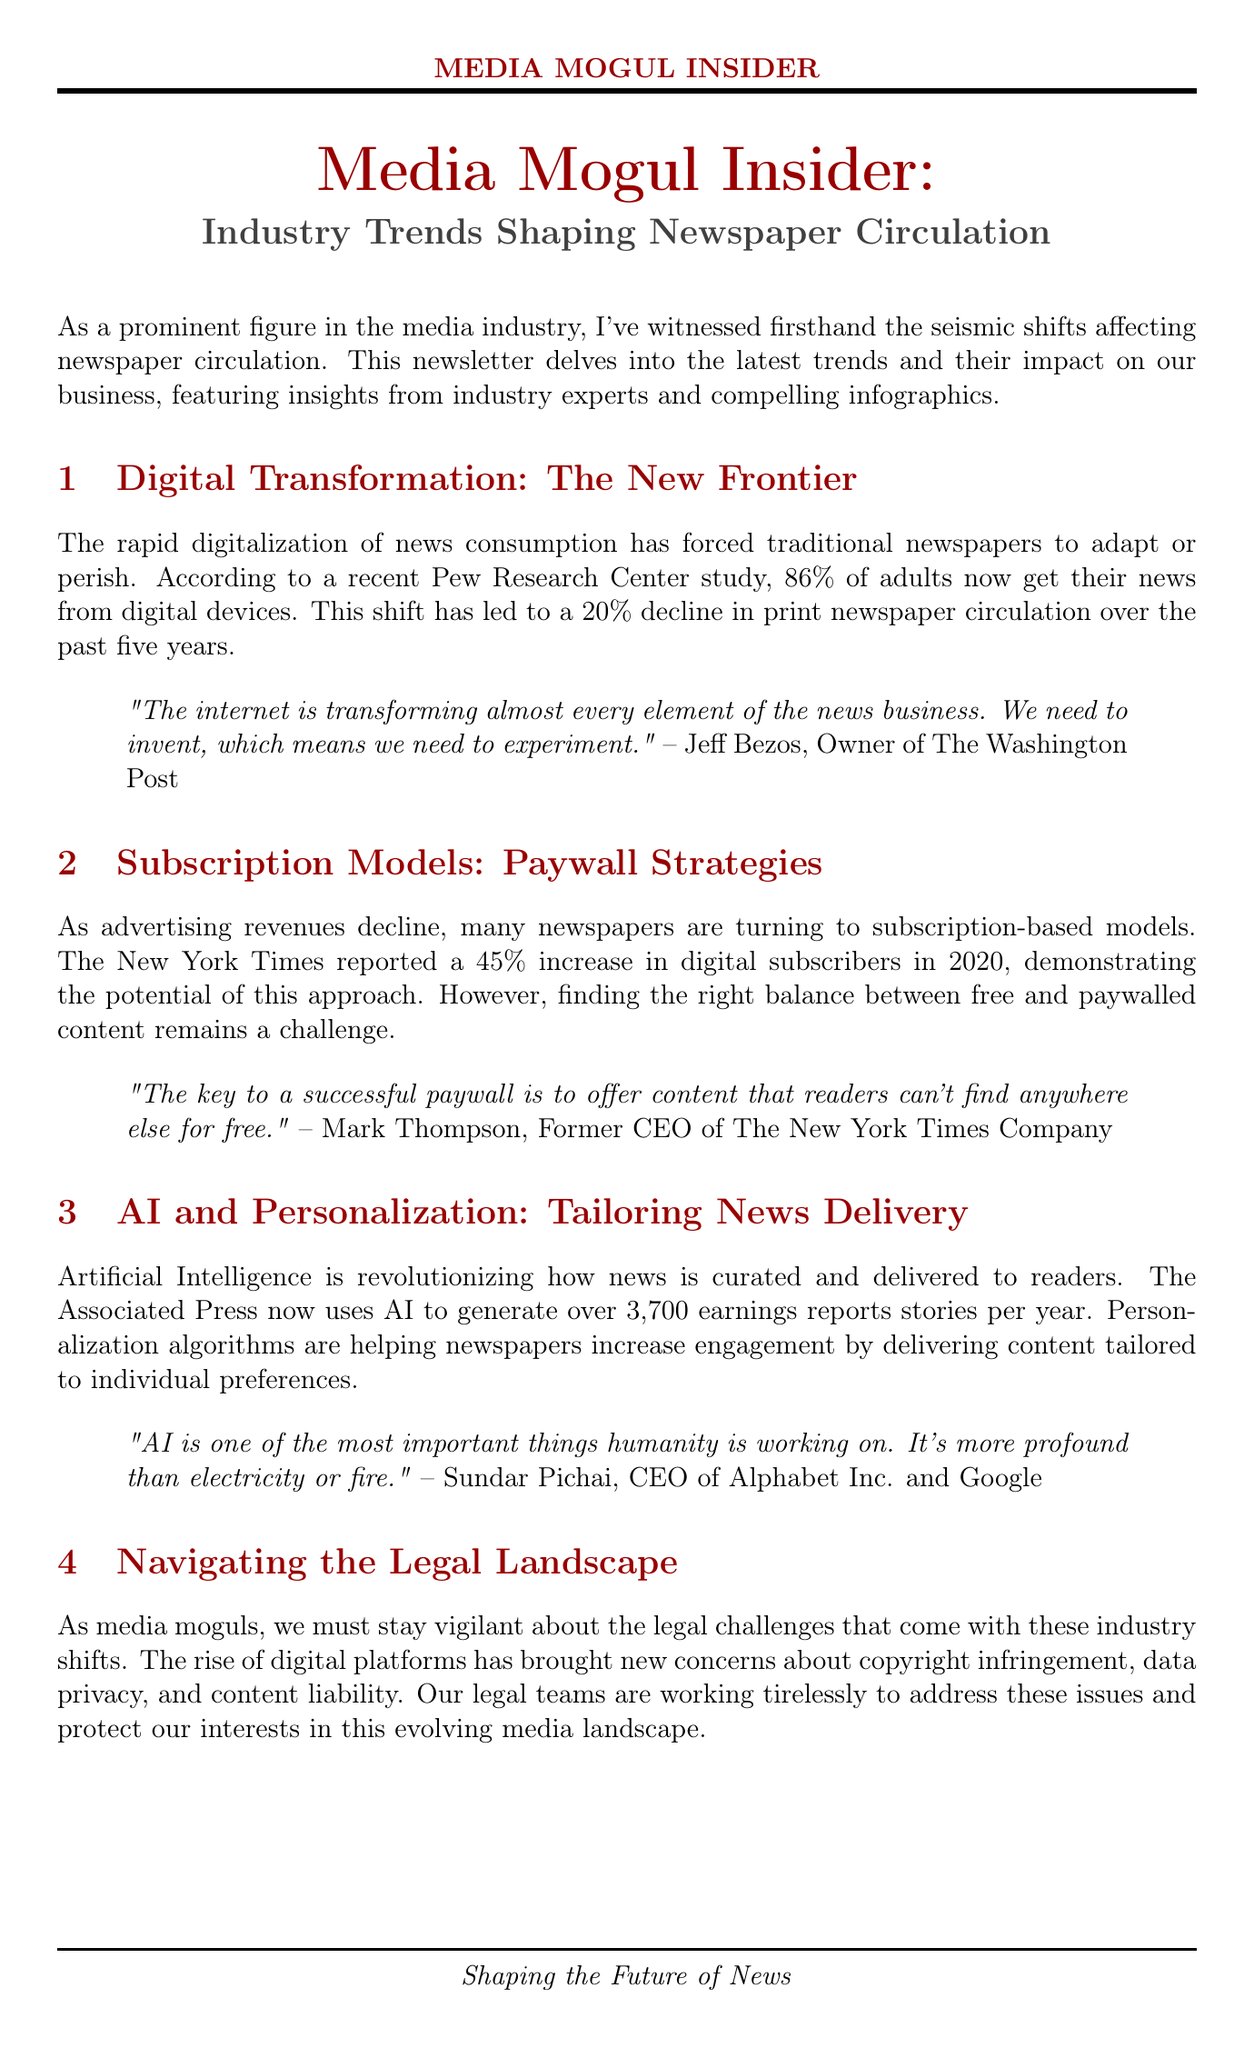what is the title of the newsletter? The title of the newsletter is provided at the beginning of the document, which encapsulates its main theme and focus.
Answer: Media Mogul Insider: Industry Trends Shaping Newspaper Circulation what percentage of adults get their news from digital devices? The document cites a specific statistic from a study, indicating the proportion of adults consuming news digitally.
Answer: 86% what was the decline percentage in print newspaper circulation over the past five years? This statistic is mentioned in the context of digital transformation's impact on traditional newspapers.
Answer: 20% who is the owner of The Washington Post? An expert quote within the document identifies the individual holding this position, which adds credibility to the insights shared.
Answer: Jeff Bezos what is the increase in digital subscribers for The New York Times in 2020? This specific figure is included to illustrate the effectiveness of subscription models in response to declining advertising revenues.
Answer: 45% what technology is revolutionizing news curation and delivery? The document elaborates on advancements affecting news delivery methods, leading to increasing engagement.
Answer: Artificial Intelligence what are the two key legal cases mentioned in the newsletter? The newsletter highlights critical legal cases relevant to the current media landscape and challenges faced by media moguls.
Answer: Google LLC v. Oracle America, Inc. and New York Times Co. v. Sullivan who stated that "AI is one of the most important things humanity is working on"? This quotation illustrates the importance of AI in the media industry, providing a notable opinion from a recognized authority.
Answer: Sundar Pichai what is emphasized as key to survival in the media industry? The conclusion of the newsletter summarizes the primary strategies for media businesses to thrive.
Answer: Adaptation and innovation 